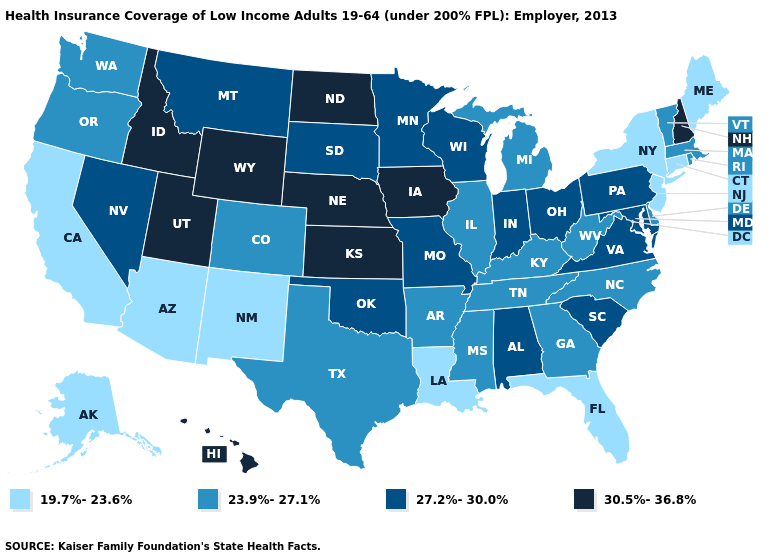Does Illinois have the lowest value in the MidWest?
Quick response, please. Yes. Is the legend a continuous bar?
Write a very short answer. No. Does New Mexico have a lower value than California?
Concise answer only. No. What is the value of New Mexico?
Be succinct. 19.7%-23.6%. Which states hav the highest value in the South?
Give a very brief answer. Alabama, Maryland, Oklahoma, South Carolina, Virginia. What is the highest value in states that border New Hampshire?
Give a very brief answer. 23.9%-27.1%. Does Oklahoma have the highest value in the South?
Quick response, please. Yes. Which states have the lowest value in the Northeast?
Give a very brief answer. Connecticut, Maine, New Jersey, New York. Which states have the highest value in the USA?
Concise answer only. Hawaii, Idaho, Iowa, Kansas, Nebraska, New Hampshire, North Dakota, Utah, Wyoming. What is the value of Maryland?
Concise answer only. 27.2%-30.0%. Name the states that have a value in the range 27.2%-30.0%?
Answer briefly. Alabama, Indiana, Maryland, Minnesota, Missouri, Montana, Nevada, Ohio, Oklahoma, Pennsylvania, South Carolina, South Dakota, Virginia, Wisconsin. Does New York have a lower value than Connecticut?
Write a very short answer. No. What is the lowest value in the USA?
Short answer required. 19.7%-23.6%. What is the lowest value in states that border Massachusetts?
Short answer required. 19.7%-23.6%. Does Mississippi have a lower value than New York?
Quick response, please. No. 